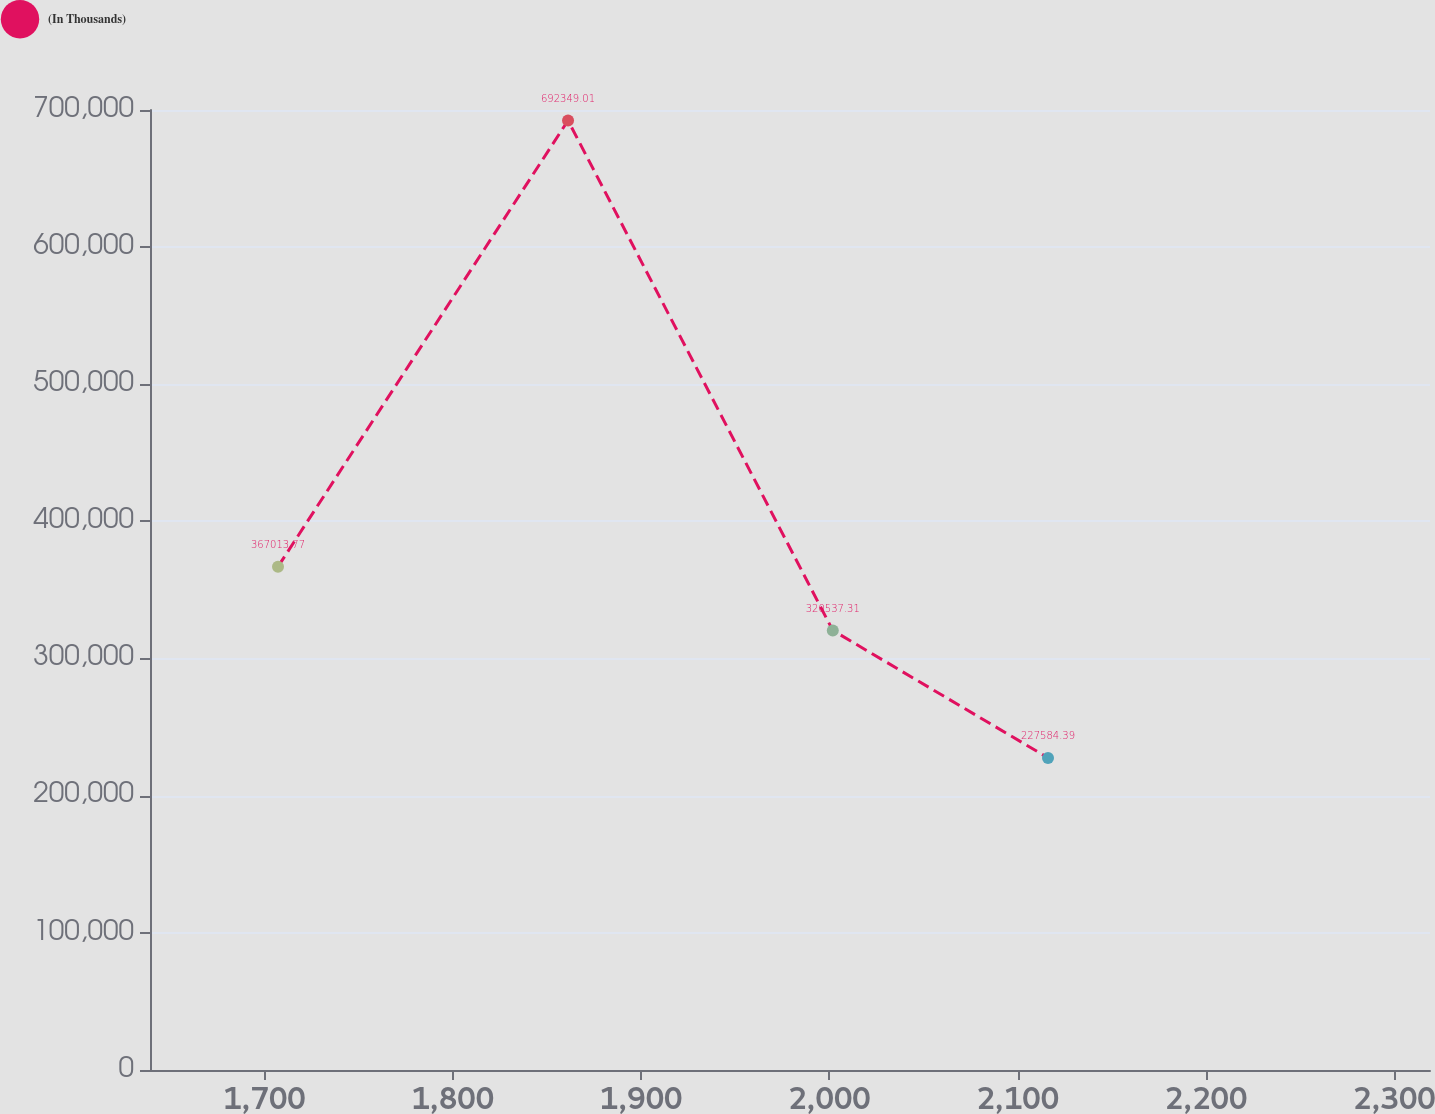<chart> <loc_0><loc_0><loc_500><loc_500><line_chart><ecel><fcel>(In Thousands)<nl><fcel>1707.19<fcel>367014<nl><fcel>1861.2<fcel>692349<nl><fcel>2001.78<fcel>320537<nl><fcel>2116.07<fcel>227584<nl><fcel>2386.87<fcel>274061<nl></chart> 